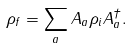<formula> <loc_0><loc_0><loc_500><loc_500>\rho _ { f } = \sum _ { a } A _ { a } \rho _ { i } A _ { a } ^ { \dagger } .</formula> 